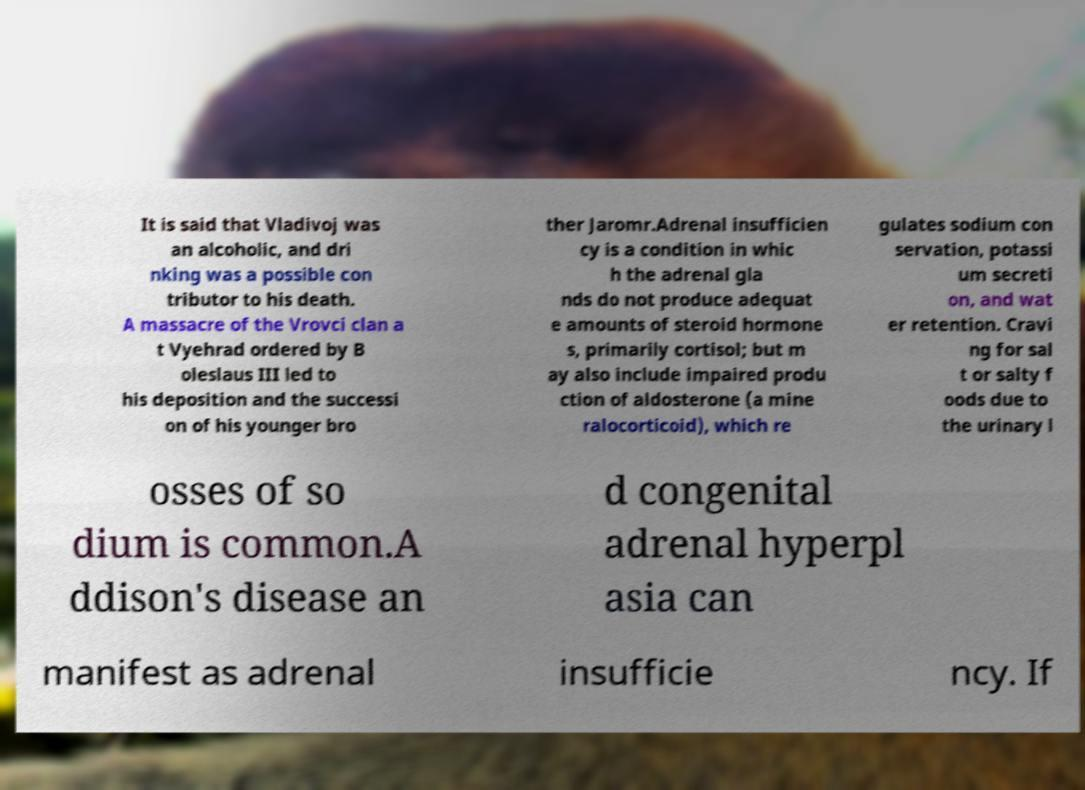Can you accurately transcribe the text from the provided image for me? It is said that Vladivoj was an alcoholic, and dri nking was a possible con tributor to his death. A massacre of the Vrovci clan a t Vyehrad ordered by B oleslaus III led to his deposition and the successi on of his younger bro ther Jaromr.Adrenal insufficien cy is a condition in whic h the adrenal gla nds do not produce adequat e amounts of steroid hormone s, primarily cortisol; but m ay also include impaired produ ction of aldosterone (a mine ralocorticoid), which re gulates sodium con servation, potassi um secreti on, and wat er retention. Cravi ng for sal t or salty f oods due to the urinary l osses of so dium is common.A ddison's disease an d congenital adrenal hyperpl asia can manifest as adrenal insufficie ncy. If 